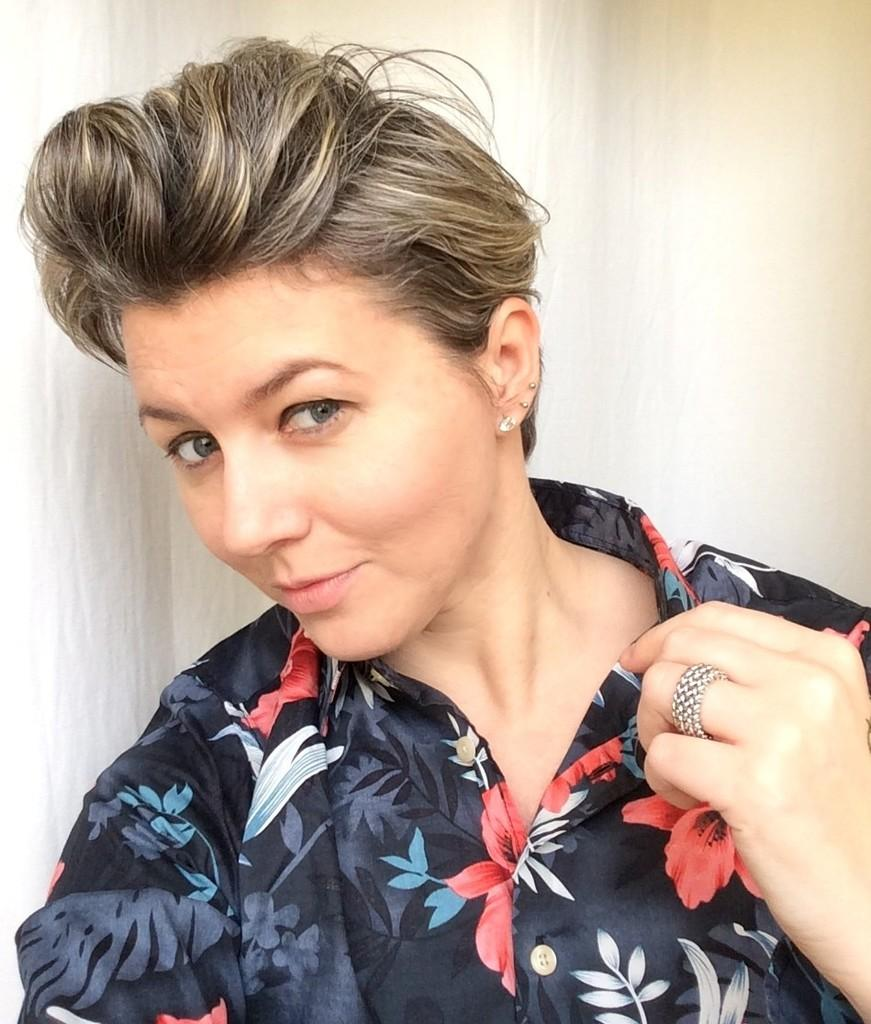Who is present in the image? There is a woman in the image. What is the woman wearing? The woman is wearing a black shirt with designs. What is the woman holding in her hand? The woman is holding a color in her hand. What can be seen in the background of the image? There is a wall visible in the background of the image. What type of wren can be seen perched on the woman's shoulder in the image? There is no wren present in the image; it only features a woman wearing a black shirt with designs, holding a color, and standing in front of a wall. 